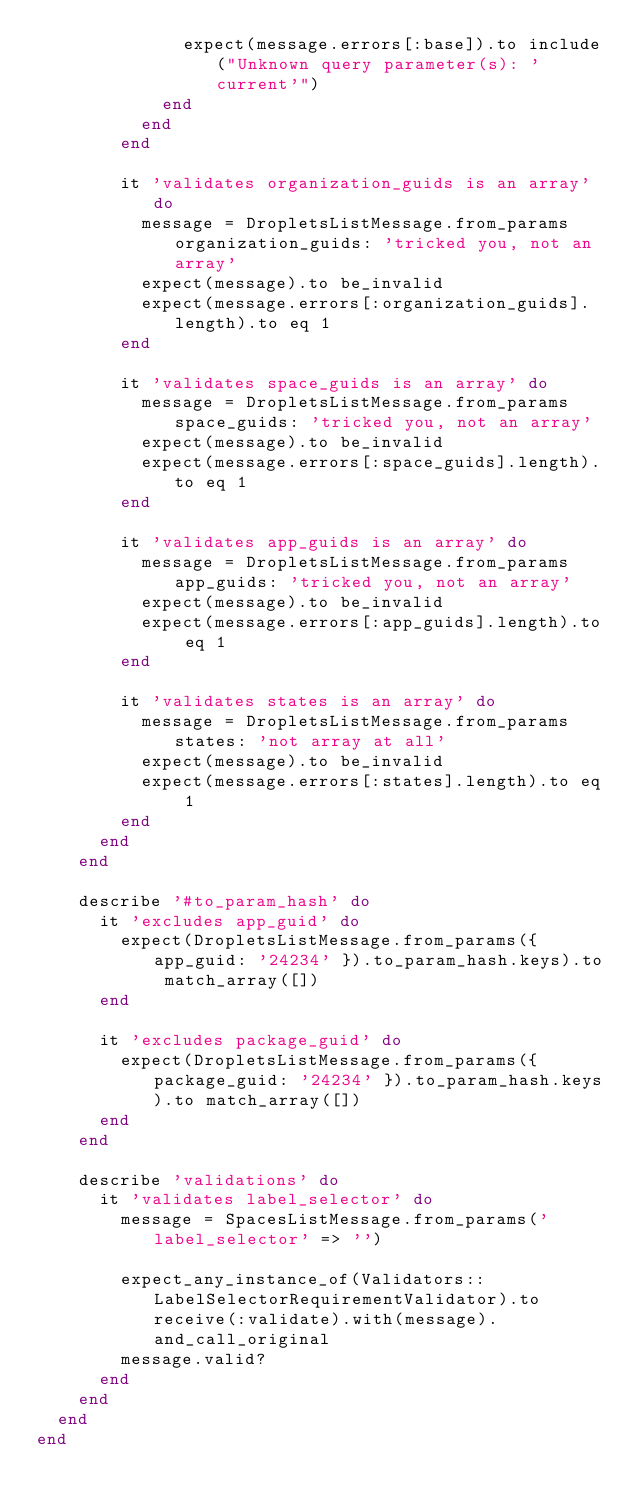Convert code to text. <code><loc_0><loc_0><loc_500><loc_500><_Ruby_>              expect(message.errors[:base]).to include("Unknown query parameter(s): 'current'")
            end
          end
        end

        it 'validates organization_guids is an array' do
          message = DropletsListMessage.from_params organization_guids: 'tricked you, not an array'
          expect(message).to be_invalid
          expect(message.errors[:organization_guids].length).to eq 1
        end

        it 'validates space_guids is an array' do
          message = DropletsListMessage.from_params space_guids: 'tricked you, not an array'
          expect(message).to be_invalid
          expect(message.errors[:space_guids].length).to eq 1
        end

        it 'validates app_guids is an array' do
          message = DropletsListMessage.from_params app_guids: 'tricked you, not an array'
          expect(message).to be_invalid
          expect(message.errors[:app_guids].length).to eq 1
        end

        it 'validates states is an array' do
          message = DropletsListMessage.from_params states: 'not array at all'
          expect(message).to be_invalid
          expect(message.errors[:states].length).to eq 1
        end
      end
    end

    describe '#to_param_hash' do
      it 'excludes app_guid' do
        expect(DropletsListMessage.from_params({ app_guid: '24234' }).to_param_hash.keys).to match_array([])
      end

      it 'excludes package_guid' do
        expect(DropletsListMessage.from_params({ package_guid: '24234' }).to_param_hash.keys).to match_array([])
      end
    end

    describe 'validations' do
      it 'validates label_selector' do
        message = SpacesListMessage.from_params('label_selector' => '')

        expect_any_instance_of(Validators::LabelSelectorRequirementValidator).to receive(:validate).with(message).and_call_original
        message.valid?
      end
    end
  end
end
</code> 